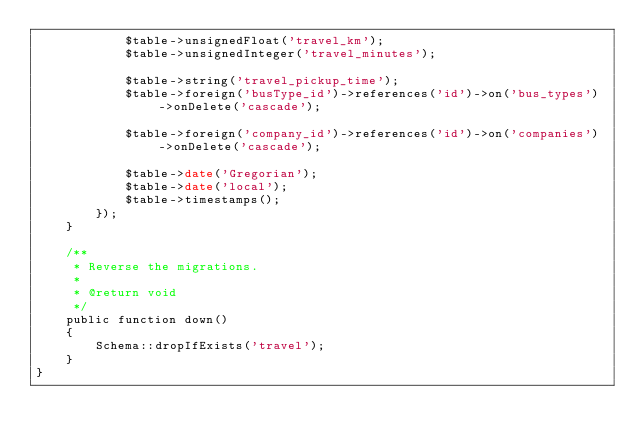<code> <loc_0><loc_0><loc_500><loc_500><_PHP_>            $table->unsignedFloat('travel_km');
            $table->unsignedInteger('travel_minutes');

            $table->string('travel_pickup_time');
            $table->foreign('busType_id')->references('id')->on('bus_types')->onDelete('cascade');

            $table->foreign('company_id')->references('id')->on('companies')->onDelete('cascade');

            $table->date('Gregorian');
            $table->date('local');
            $table->timestamps();
        });
    }

    /**
     * Reverse the migrations.
     *
     * @return void
     */
    public function down()
    {
        Schema::dropIfExists('travel');
    }
}
</code> 